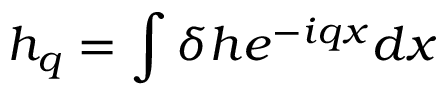Convert formula to latex. <formula><loc_0><loc_0><loc_500><loc_500>h _ { q } = \int { \delta h { { e } ^ { - i q x } } d x }</formula> 